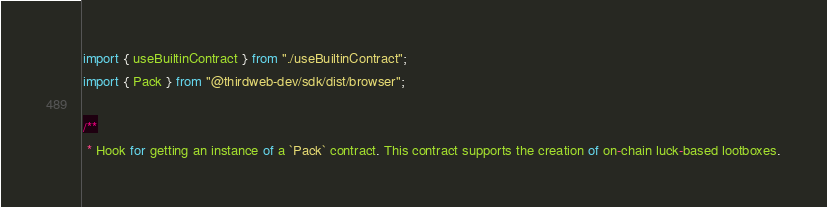<code> <loc_0><loc_0><loc_500><loc_500><_TypeScript_>import { useBuiltinContract } from "./useBuiltinContract";
import { Pack } from "@thirdweb-dev/sdk/dist/browser";

/**
 * Hook for getting an instance of a `Pack` contract. This contract supports the creation of on-chain luck-based lootboxes.</code> 